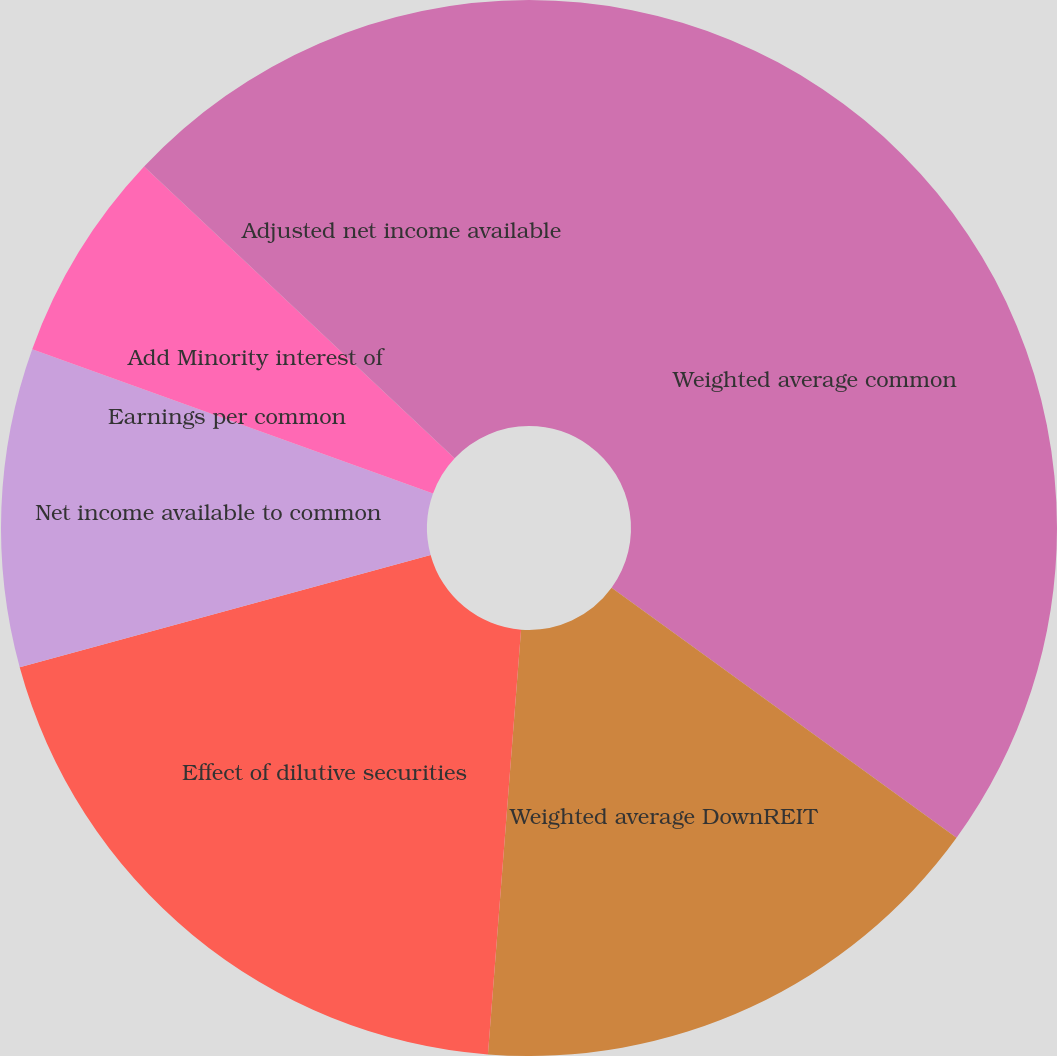Convert chart. <chart><loc_0><loc_0><loc_500><loc_500><pie_chart><fcel>Weighted average common<fcel>Weighted average DownREIT<fcel>Effect of dilutive securities<fcel>Net income available to common<fcel>Earnings per common<fcel>Add Minority interest of<fcel>Adjusted net income available<nl><fcel>34.98%<fcel>16.26%<fcel>19.51%<fcel>9.75%<fcel>0.0%<fcel>6.5%<fcel>13.0%<nl></chart> 